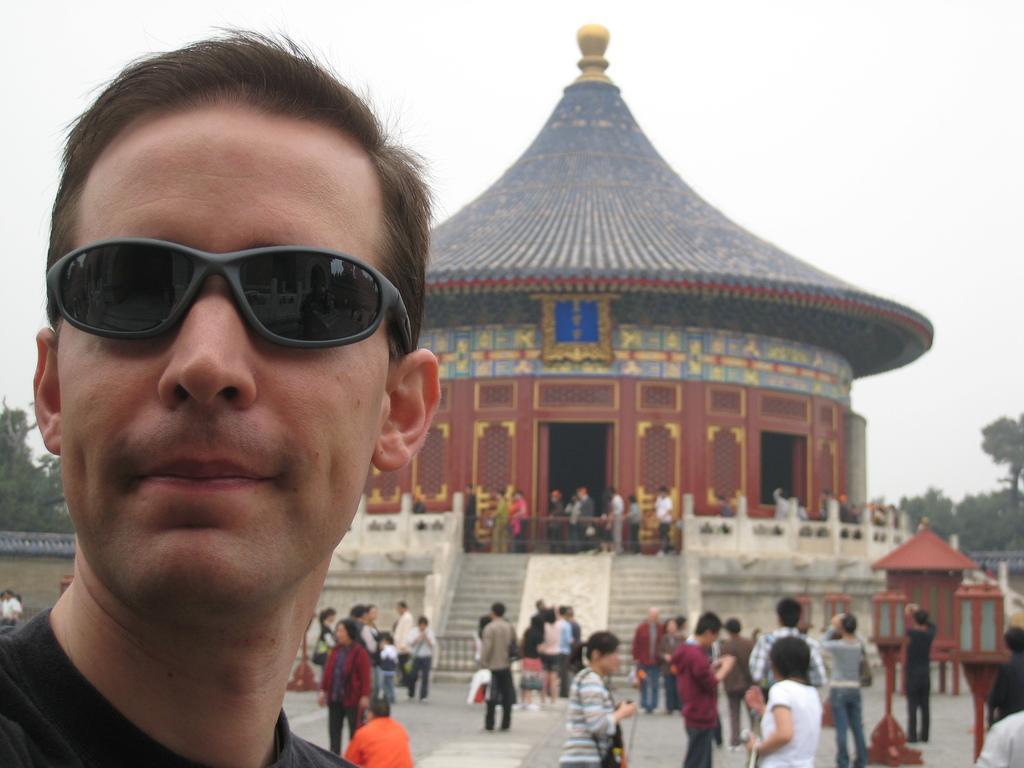Please provide a concise description of this image. In the image we can see there is a man and he is wearing sunglasses. There are other people standing on the ground and there are stairs. There is a building and behind there are trees. Background of the image is little blurred. 